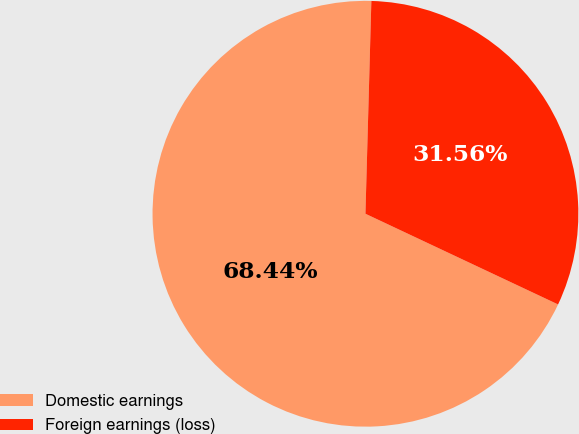Convert chart to OTSL. <chart><loc_0><loc_0><loc_500><loc_500><pie_chart><fcel>Domestic earnings<fcel>Foreign earnings (loss)<nl><fcel>68.44%<fcel>31.56%<nl></chart> 